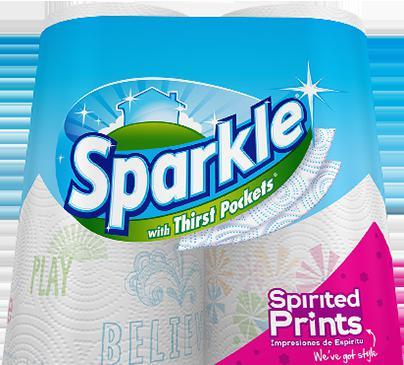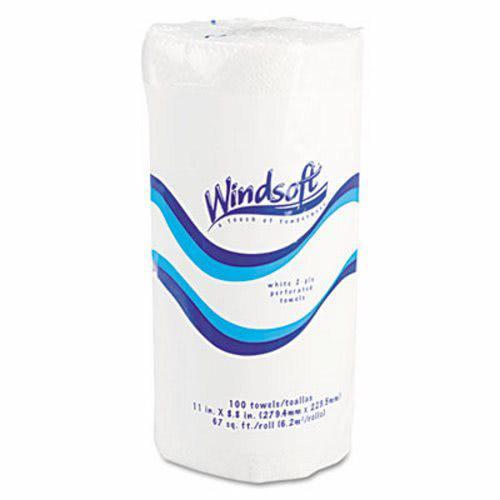The first image is the image on the left, the second image is the image on the right. Evaluate the accuracy of this statement regarding the images: "The left image shows one multi-roll package of towels with a starburst shape on the front of the pack, and the package on the right features a blue curving line.". Is it true? Answer yes or no. Yes. The first image is the image on the left, the second image is the image on the right. Assess this claim about the two images: "There are two multi-packs of paper towels.". Correct or not? Answer yes or no. No. 